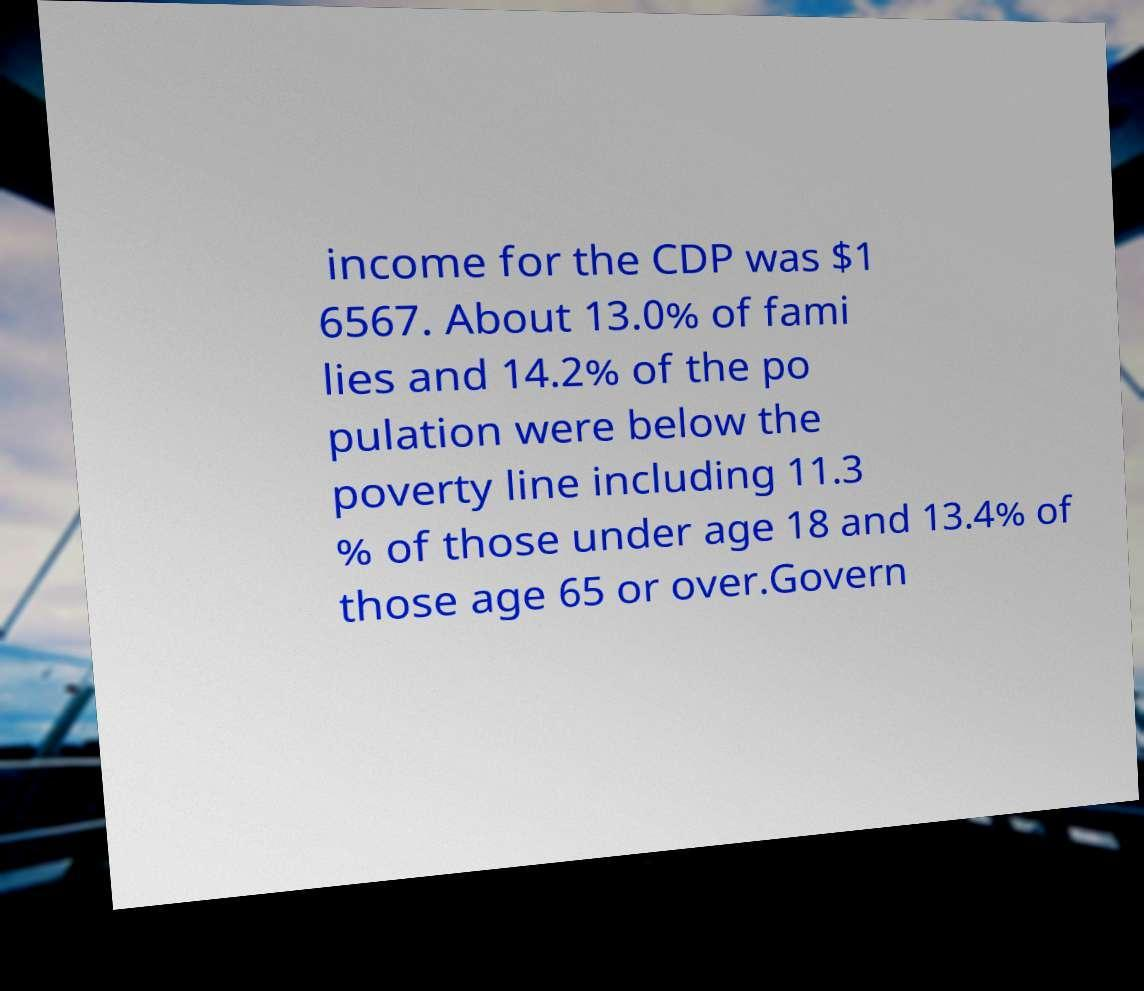Please identify and transcribe the text found in this image. income for the CDP was $1 6567. About 13.0% of fami lies and 14.2% of the po pulation were below the poverty line including 11.3 % of those under age 18 and 13.4% of those age 65 or over.Govern 